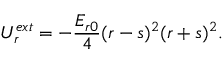Convert formula to latex. <formula><loc_0><loc_0><loc_500><loc_500>U _ { r } ^ { e x t } = - \frac { { E _ { r 0 } } } { 4 } { ( r - s ) ^ { 2 } } { ( r + s ) ^ { 2 } } { . }</formula> 